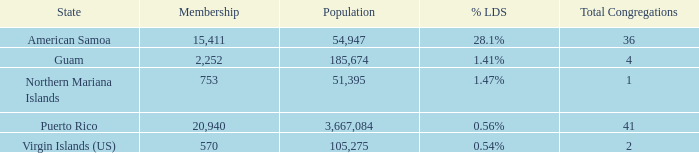What is the total number of Total Congregations, when % LDS is 0.54%, and when Population is greater than 105,275? 0.0. 